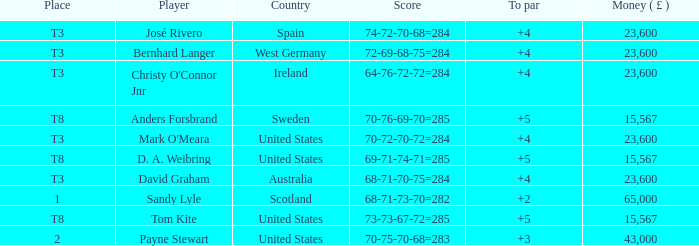What place is David Graham in? T3. 